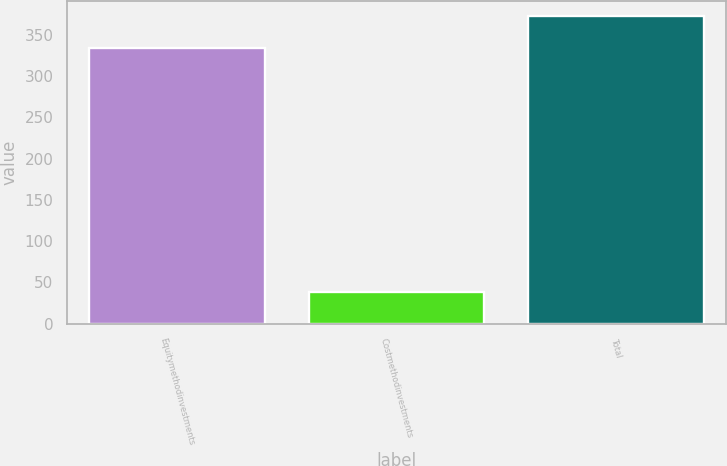<chart> <loc_0><loc_0><loc_500><loc_500><bar_chart><fcel>Equitymethodinvestments<fcel>Costmethodinvestments<fcel>Total<nl><fcel>334.4<fcel>37.9<fcel>372.3<nl></chart> 